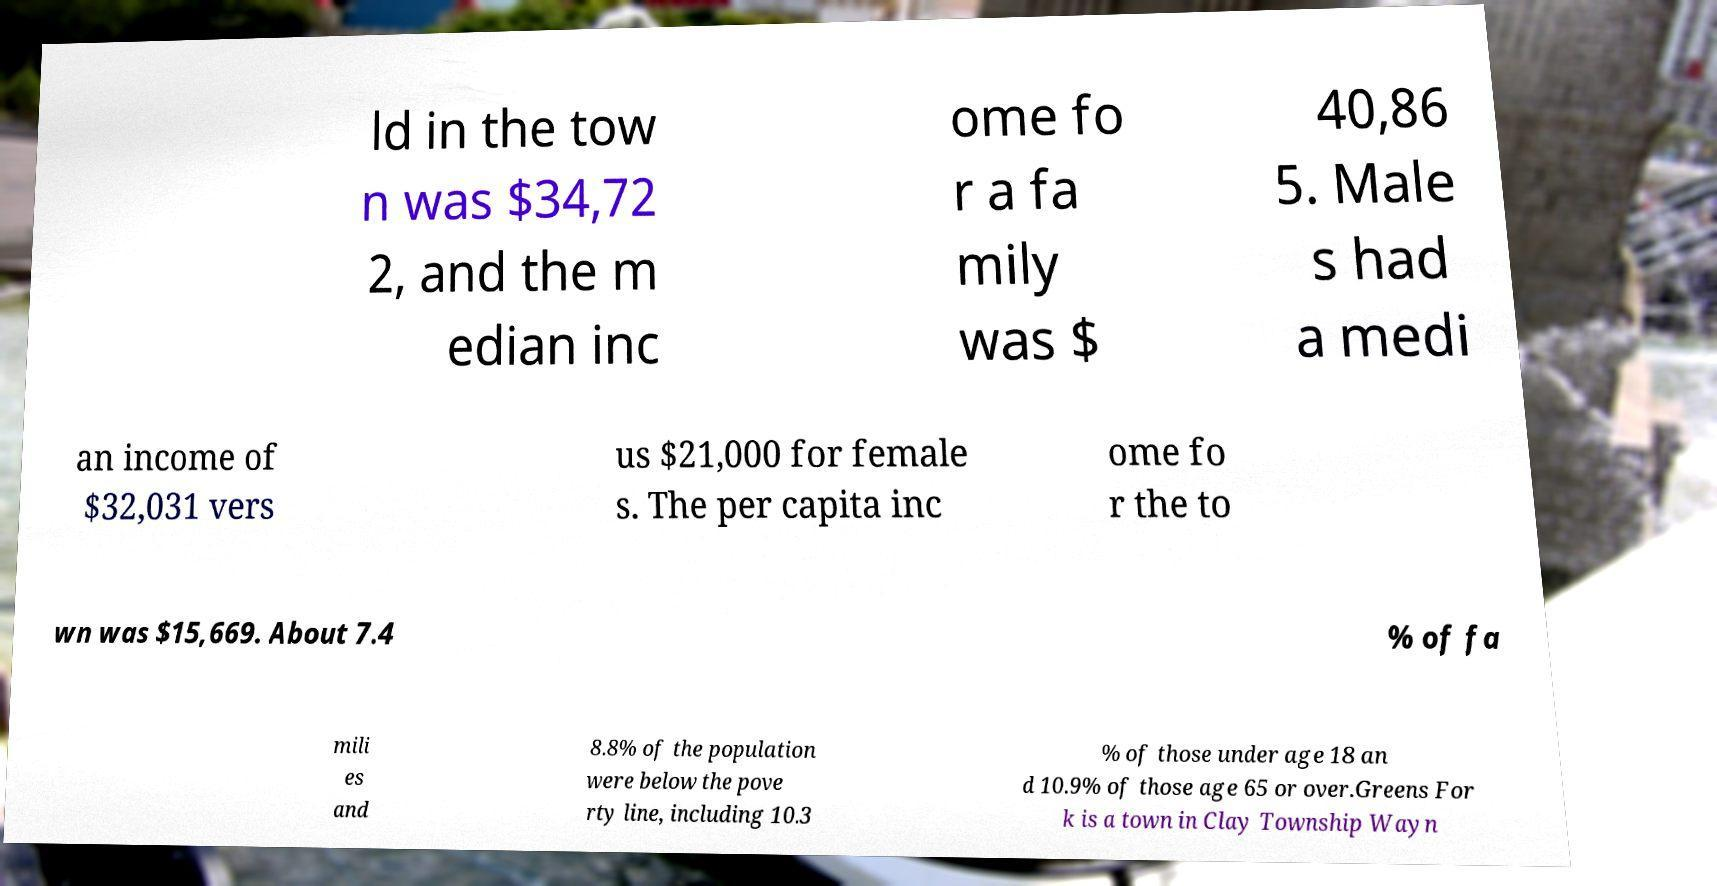For documentation purposes, I need the text within this image transcribed. Could you provide that? ld in the tow n was $34,72 2, and the m edian inc ome fo r a fa mily was $ 40,86 5. Male s had a medi an income of $32,031 vers us $21,000 for female s. The per capita inc ome fo r the to wn was $15,669. About 7.4 % of fa mili es and 8.8% of the population were below the pove rty line, including 10.3 % of those under age 18 an d 10.9% of those age 65 or over.Greens For k is a town in Clay Township Wayn 